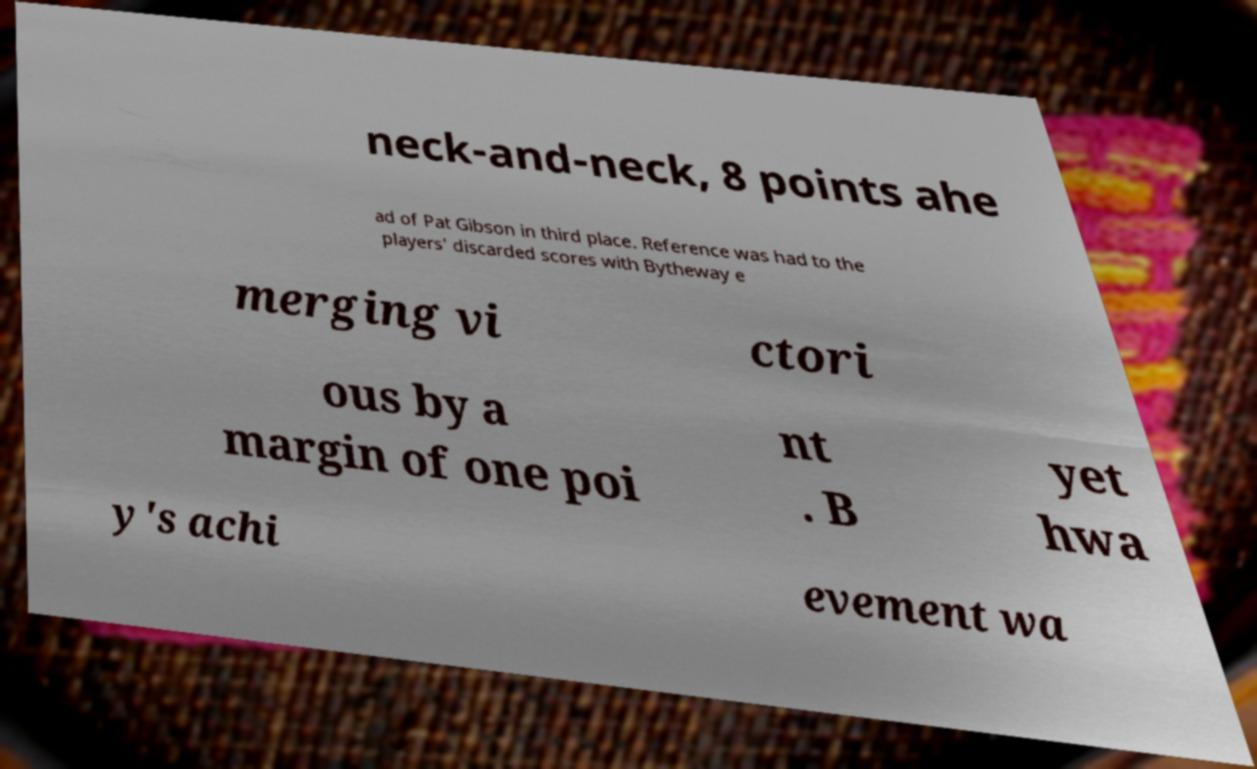I need the written content from this picture converted into text. Can you do that? neck-and-neck, 8 points ahe ad of Pat Gibson in third place. Reference was had to the players' discarded scores with Bytheway e merging vi ctori ous by a margin of one poi nt . B yet hwa y's achi evement wa 